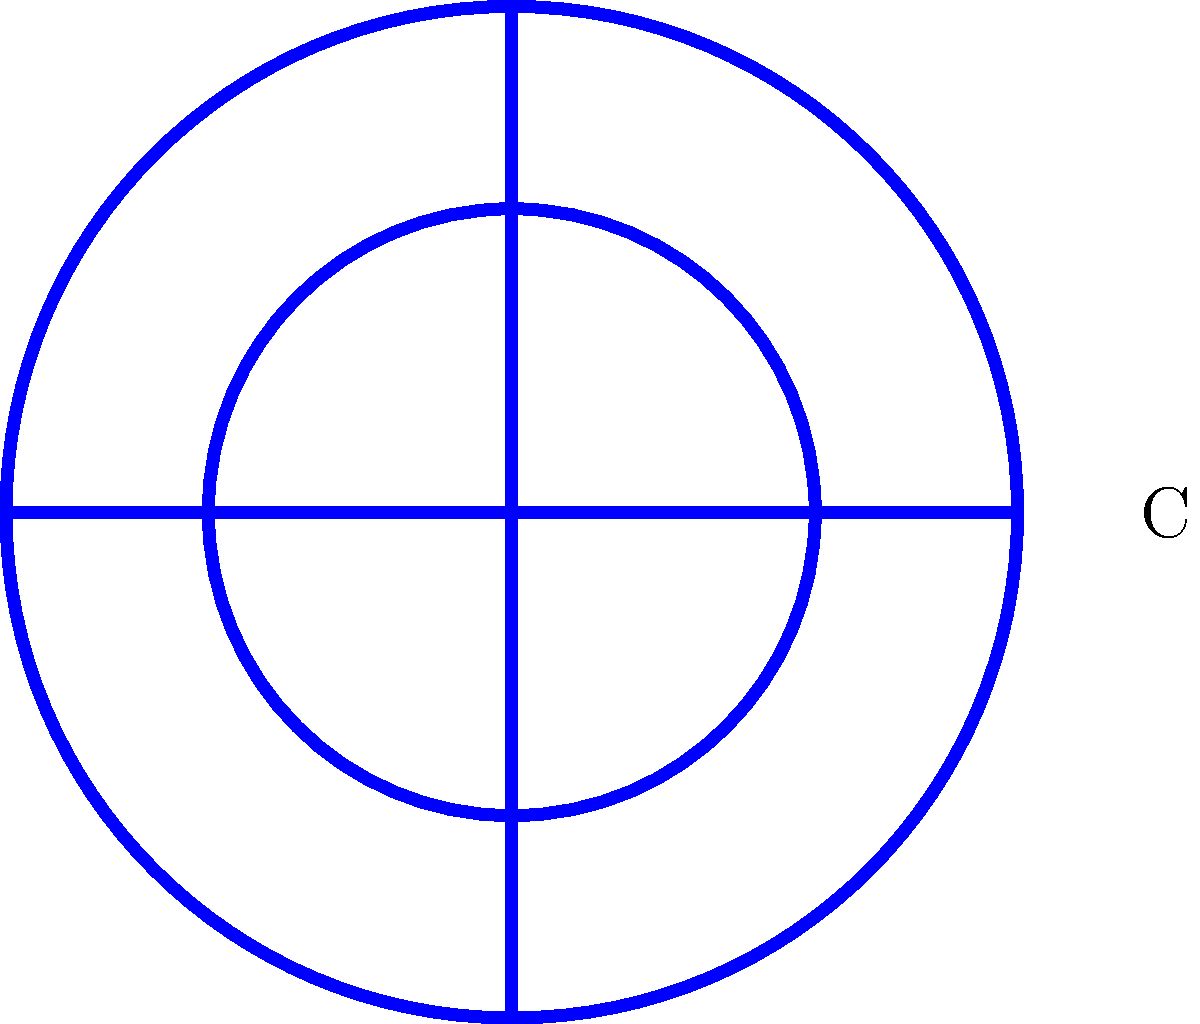Consider the cryptocurrency logo shown above. What is the order of its symmetry group? To determine the order of the symmetry group for this cryptocurrency logo, we need to identify all the symmetry operations that leave the logo unchanged. Let's analyze the logo step-by-step:

1. Rotational symmetry:
   The logo has 4-fold rotational symmetry, meaning it remains unchanged when rotated by 90°, 180°, 270°, and 360° (which is equivalent to 0°).

2. Reflection symmetry:
   The logo has 4 lines of reflection symmetry:
   - Vertical line
   - Horizontal line
   - Two diagonal lines (45° and 135°)

3. Identity transformation:
   The identity transformation (no change) is always a symmetry operation.

Now, let's count all these symmetry operations:
- 4 rotations (including the identity)
- 4 reflections

The total number of symmetry operations is 4 + 4 = 8.

In group theory, the order of a group is the number of elements in the group. Since each symmetry operation corresponds to an element in the symmetry group, the order of the symmetry group is equal to the number of symmetry operations.

Therefore, the order of the symmetry group for this cryptocurrency logo is 8.

Note: This symmetry group is isomorphic to the dihedral group $D_4$, which is the symmetry group of a square.
Answer: 8 